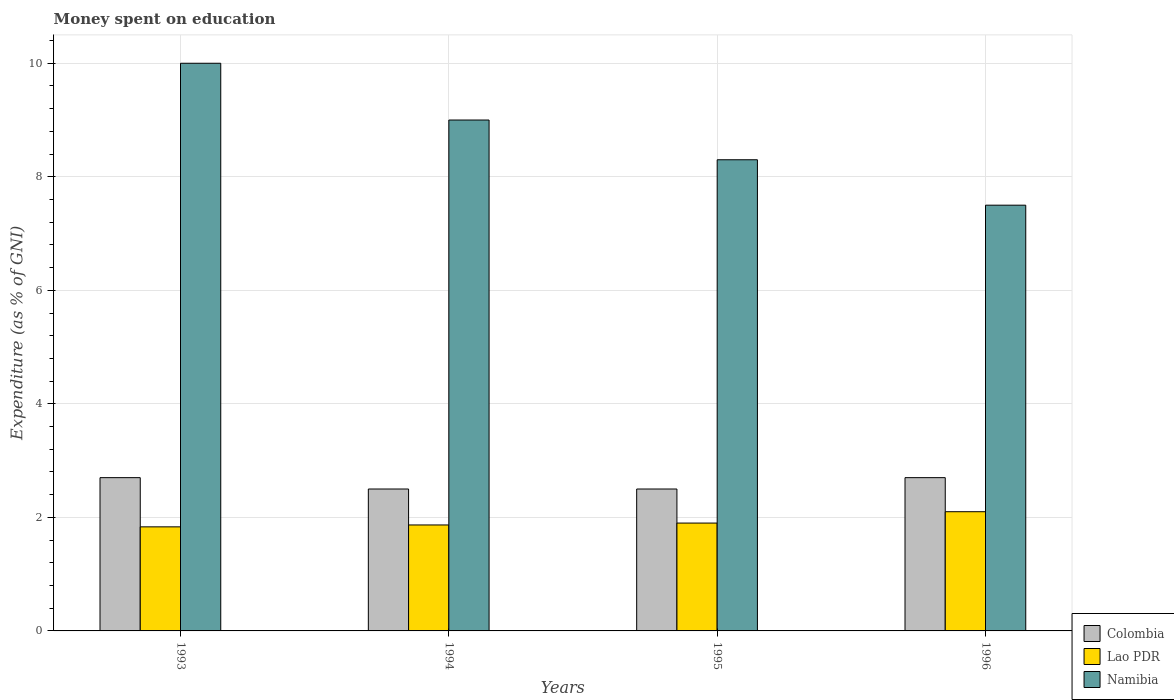How many different coloured bars are there?
Your answer should be very brief. 3. How many groups of bars are there?
Give a very brief answer. 4. Are the number of bars on each tick of the X-axis equal?
Your response must be concise. Yes. How many bars are there on the 4th tick from the left?
Your answer should be very brief. 3. What is the label of the 4th group of bars from the left?
Provide a short and direct response. 1996. What is the amount of money spent on education in Namibia in 1993?
Your response must be concise. 10. Across all years, what is the maximum amount of money spent on education in Colombia?
Keep it short and to the point. 2.7. What is the total amount of money spent on education in Namibia in the graph?
Offer a very short reply. 34.8. What is the difference between the amount of money spent on education in Colombia in 1994 and that in 1996?
Make the answer very short. -0.2. What is the difference between the amount of money spent on education in Colombia in 1993 and the amount of money spent on education in Lao PDR in 1995?
Keep it short and to the point. 0.8. In the year 1994, what is the difference between the amount of money spent on education in Colombia and amount of money spent on education in Lao PDR?
Offer a terse response. 0.63. What is the ratio of the amount of money spent on education in Namibia in 1995 to that in 1996?
Offer a terse response. 1.11. Is the amount of money spent on education in Lao PDR in 1994 less than that in 1996?
Provide a succinct answer. Yes. What is the difference between the highest and the second highest amount of money spent on education in Lao PDR?
Your answer should be compact. 0.2. What is the difference between the highest and the lowest amount of money spent on education in Lao PDR?
Provide a short and direct response. 0.27. Is the sum of the amount of money spent on education in Lao PDR in 1994 and 1995 greater than the maximum amount of money spent on education in Colombia across all years?
Give a very brief answer. Yes. What does the 3rd bar from the left in 1994 represents?
Your answer should be compact. Namibia. What does the 3rd bar from the right in 1995 represents?
Your answer should be very brief. Colombia. Is it the case that in every year, the sum of the amount of money spent on education in Namibia and amount of money spent on education in Colombia is greater than the amount of money spent on education in Lao PDR?
Keep it short and to the point. Yes. Does the graph contain grids?
Keep it short and to the point. Yes. Where does the legend appear in the graph?
Offer a terse response. Bottom right. How many legend labels are there?
Offer a very short reply. 3. What is the title of the graph?
Provide a short and direct response. Money spent on education. Does "Sweden" appear as one of the legend labels in the graph?
Offer a very short reply. No. What is the label or title of the X-axis?
Keep it short and to the point. Years. What is the label or title of the Y-axis?
Make the answer very short. Expenditure (as % of GNI). What is the Expenditure (as % of GNI) in Colombia in 1993?
Offer a terse response. 2.7. What is the Expenditure (as % of GNI) of Lao PDR in 1993?
Ensure brevity in your answer.  1.83. What is the Expenditure (as % of GNI) in Namibia in 1993?
Ensure brevity in your answer.  10. What is the Expenditure (as % of GNI) of Lao PDR in 1994?
Your answer should be compact. 1.87. What is the Expenditure (as % of GNI) of Colombia in 1995?
Make the answer very short. 2.5. What is the Expenditure (as % of GNI) of Lao PDR in 1995?
Your answer should be very brief. 1.9. What is the Expenditure (as % of GNI) of Namibia in 1996?
Provide a short and direct response. 7.5. Across all years, what is the maximum Expenditure (as % of GNI) of Lao PDR?
Your response must be concise. 2.1. Across all years, what is the maximum Expenditure (as % of GNI) of Namibia?
Make the answer very short. 10. Across all years, what is the minimum Expenditure (as % of GNI) of Lao PDR?
Your response must be concise. 1.83. Across all years, what is the minimum Expenditure (as % of GNI) of Namibia?
Give a very brief answer. 7.5. What is the total Expenditure (as % of GNI) in Namibia in the graph?
Your answer should be very brief. 34.8. What is the difference between the Expenditure (as % of GNI) in Colombia in 1993 and that in 1994?
Keep it short and to the point. 0.2. What is the difference between the Expenditure (as % of GNI) in Lao PDR in 1993 and that in 1994?
Ensure brevity in your answer.  -0.03. What is the difference between the Expenditure (as % of GNI) in Namibia in 1993 and that in 1994?
Provide a succinct answer. 1. What is the difference between the Expenditure (as % of GNI) of Colombia in 1993 and that in 1995?
Your response must be concise. 0.2. What is the difference between the Expenditure (as % of GNI) of Lao PDR in 1993 and that in 1995?
Provide a short and direct response. -0.07. What is the difference between the Expenditure (as % of GNI) of Namibia in 1993 and that in 1995?
Your answer should be very brief. 1.7. What is the difference between the Expenditure (as % of GNI) in Lao PDR in 1993 and that in 1996?
Provide a succinct answer. -0.27. What is the difference between the Expenditure (as % of GNI) in Colombia in 1994 and that in 1995?
Give a very brief answer. 0. What is the difference between the Expenditure (as % of GNI) of Lao PDR in 1994 and that in 1995?
Your answer should be compact. -0.03. What is the difference between the Expenditure (as % of GNI) of Colombia in 1994 and that in 1996?
Provide a short and direct response. -0.2. What is the difference between the Expenditure (as % of GNI) of Lao PDR in 1994 and that in 1996?
Offer a very short reply. -0.23. What is the difference between the Expenditure (as % of GNI) of Namibia in 1994 and that in 1996?
Your answer should be compact. 1.5. What is the difference between the Expenditure (as % of GNI) in Lao PDR in 1995 and that in 1996?
Make the answer very short. -0.2. What is the difference between the Expenditure (as % of GNI) of Namibia in 1995 and that in 1996?
Ensure brevity in your answer.  0.8. What is the difference between the Expenditure (as % of GNI) in Lao PDR in 1993 and the Expenditure (as % of GNI) in Namibia in 1994?
Provide a short and direct response. -7.17. What is the difference between the Expenditure (as % of GNI) of Colombia in 1993 and the Expenditure (as % of GNI) of Lao PDR in 1995?
Your answer should be very brief. 0.8. What is the difference between the Expenditure (as % of GNI) in Colombia in 1993 and the Expenditure (as % of GNI) in Namibia in 1995?
Provide a succinct answer. -5.6. What is the difference between the Expenditure (as % of GNI) of Lao PDR in 1993 and the Expenditure (as % of GNI) of Namibia in 1995?
Keep it short and to the point. -6.47. What is the difference between the Expenditure (as % of GNI) in Colombia in 1993 and the Expenditure (as % of GNI) in Lao PDR in 1996?
Provide a succinct answer. 0.6. What is the difference between the Expenditure (as % of GNI) of Colombia in 1993 and the Expenditure (as % of GNI) of Namibia in 1996?
Provide a succinct answer. -4.8. What is the difference between the Expenditure (as % of GNI) of Lao PDR in 1993 and the Expenditure (as % of GNI) of Namibia in 1996?
Ensure brevity in your answer.  -5.67. What is the difference between the Expenditure (as % of GNI) of Colombia in 1994 and the Expenditure (as % of GNI) of Namibia in 1995?
Your response must be concise. -5.8. What is the difference between the Expenditure (as % of GNI) in Lao PDR in 1994 and the Expenditure (as % of GNI) in Namibia in 1995?
Make the answer very short. -6.43. What is the difference between the Expenditure (as % of GNI) of Colombia in 1994 and the Expenditure (as % of GNI) of Lao PDR in 1996?
Your response must be concise. 0.4. What is the difference between the Expenditure (as % of GNI) of Lao PDR in 1994 and the Expenditure (as % of GNI) of Namibia in 1996?
Offer a very short reply. -5.63. What is the average Expenditure (as % of GNI) in Lao PDR per year?
Your response must be concise. 1.93. In the year 1993, what is the difference between the Expenditure (as % of GNI) of Colombia and Expenditure (as % of GNI) of Lao PDR?
Your answer should be very brief. 0.87. In the year 1993, what is the difference between the Expenditure (as % of GNI) in Lao PDR and Expenditure (as % of GNI) in Namibia?
Your answer should be compact. -8.17. In the year 1994, what is the difference between the Expenditure (as % of GNI) in Colombia and Expenditure (as % of GNI) in Lao PDR?
Provide a succinct answer. 0.63. In the year 1994, what is the difference between the Expenditure (as % of GNI) in Lao PDR and Expenditure (as % of GNI) in Namibia?
Keep it short and to the point. -7.13. In the year 1995, what is the difference between the Expenditure (as % of GNI) in Colombia and Expenditure (as % of GNI) in Lao PDR?
Ensure brevity in your answer.  0.6. In the year 1996, what is the difference between the Expenditure (as % of GNI) in Colombia and Expenditure (as % of GNI) in Lao PDR?
Your answer should be compact. 0.6. In the year 1996, what is the difference between the Expenditure (as % of GNI) in Colombia and Expenditure (as % of GNI) in Namibia?
Make the answer very short. -4.8. In the year 1996, what is the difference between the Expenditure (as % of GNI) of Lao PDR and Expenditure (as % of GNI) of Namibia?
Provide a succinct answer. -5.4. What is the ratio of the Expenditure (as % of GNI) of Lao PDR in 1993 to that in 1994?
Provide a short and direct response. 0.98. What is the ratio of the Expenditure (as % of GNI) in Namibia in 1993 to that in 1994?
Give a very brief answer. 1.11. What is the ratio of the Expenditure (as % of GNI) of Lao PDR in 1993 to that in 1995?
Offer a very short reply. 0.96. What is the ratio of the Expenditure (as % of GNI) in Namibia in 1993 to that in 1995?
Make the answer very short. 1.2. What is the ratio of the Expenditure (as % of GNI) of Colombia in 1993 to that in 1996?
Keep it short and to the point. 1. What is the ratio of the Expenditure (as % of GNI) in Lao PDR in 1993 to that in 1996?
Offer a very short reply. 0.87. What is the ratio of the Expenditure (as % of GNI) of Namibia in 1993 to that in 1996?
Make the answer very short. 1.33. What is the ratio of the Expenditure (as % of GNI) in Colombia in 1994 to that in 1995?
Offer a terse response. 1. What is the ratio of the Expenditure (as % of GNI) in Lao PDR in 1994 to that in 1995?
Provide a short and direct response. 0.98. What is the ratio of the Expenditure (as % of GNI) in Namibia in 1994 to that in 1995?
Provide a short and direct response. 1.08. What is the ratio of the Expenditure (as % of GNI) in Colombia in 1994 to that in 1996?
Provide a succinct answer. 0.93. What is the ratio of the Expenditure (as % of GNI) in Lao PDR in 1994 to that in 1996?
Your answer should be compact. 0.89. What is the ratio of the Expenditure (as % of GNI) in Colombia in 1995 to that in 1996?
Offer a very short reply. 0.93. What is the ratio of the Expenditure (as % of GNI) in Lao PDR in 1995 to that in 1996?
Make the answer very short. 0.9. What is the ratio of the Expenditure (as % of GNI) of Namibia in 1995 to that in 1996?
Offer a terse response. 1.11. What is the difference between the highest and the second highest Expenditure (as % of GNI) of Colombia?
Your answer should be compact. 0. What is the difference between the highest and the second highest Expenditure (as % of GNI) in Lao PDR?
Provide a short and direct response. 0.2. What is the difference between the highest and the lowest Expenditure (as % of GNI) of Colombia?
Provide a short and direct response. 0.2. What is the difference between the highest and the lowest Expenditure (as % of GNI) in Lao PDR?
Offer a terse response. 0.27. What is the difference between the highest and the lowest Expenditure (as % of GNI) in Namibia?
Ensure brevity in your answer.  2.5. 